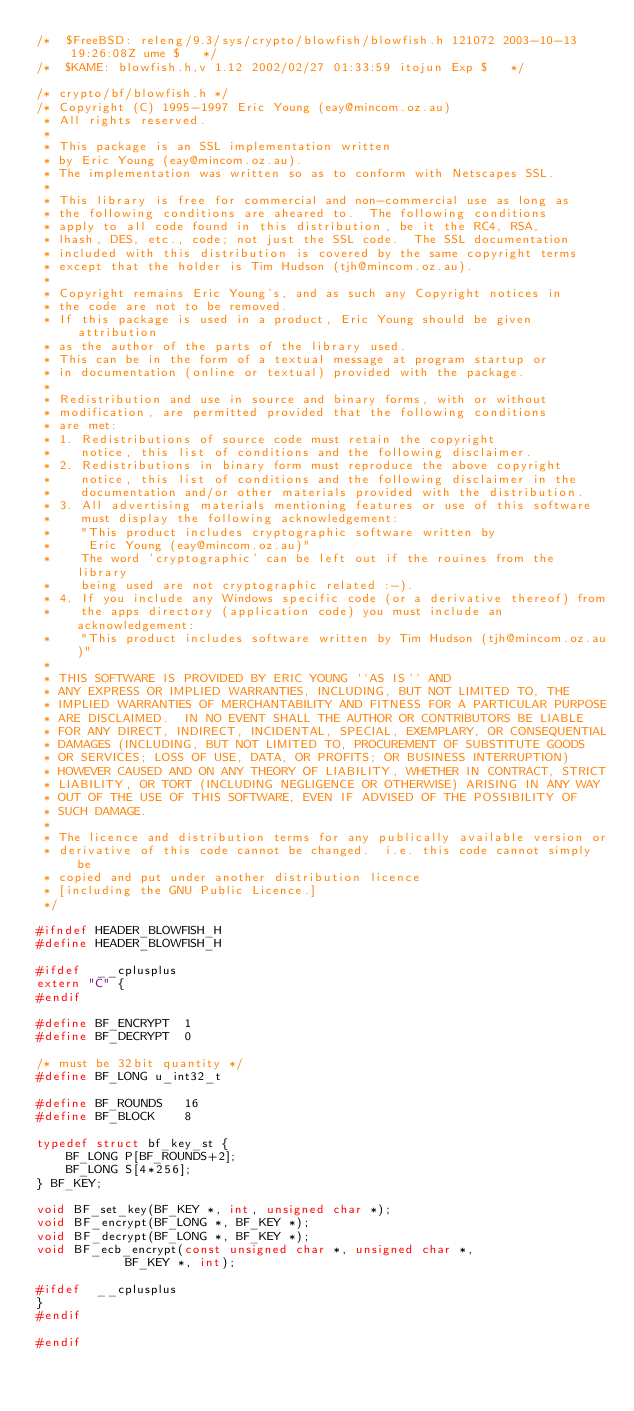Convert code to text. <code><loc_0><loc_0><loc_500><loc_500><_C_>/*	$FreeBSD: releng/9.3/sys/crypto/blowfish/blowfish.h 121072 2003-10-13 19:26:08Z ume $	*/
/*	$KAME: blowfish.h,v 1.12 2002/02/27 01:33:59 itojun Exp $	*/

/* crypto/bf/blowfish.h */
/* Copyright (C) 1995-1997 Eric Young (eay@mincom.oz.au)
 * All rights reserved.
 *
 * This package is an SSL implementation written
 * by Eric Young (eay@mincom.oz.au).
 * The implementation was written so as to conform with Netscapes SSL.
 *
 * This library is free for commercial and non-commercial use as long as
 * the following conditions are aheared to.  The following conditions
 * apply to all code found in this distribution, be it the RC4, RSA,
 * lhash, DES, etc., code; not just the SSL code.  The SSL documentation
 * included with this distribution is covered by the same copyright terms
 * except that the holder is Tim Hudson (tjh@mincom.oz.au).
 *
 * Copyright remains Eric Young's, and as such any Copyright notices in
 * the code are not to be removed.
 * If this package is used in a product, Eric Young should be given attribution
 * as the author of the parts of the library used.
 * This can be in the form of a textual message at program startup or
 * in documentation (online or textual) provided with the package.
 *
 * Redistribution and use in source and binary forms, with or without
 * modification, are permitted provided that the following conditions
 * are met:
 * 1. Redistributions of source code must retain the copyright
 *    notice, this list of conditions and the following disclaimer.
 * 2. Redistributions in binary form must reproduce the above copyright
 *    notice, this list of conditions and the following disclaimer in the
 *    documentation and/or other materials provided with the distribution.
 * 3. All advertising materials mentioning features or use of this software
 *    must display the following acknowledgement:
 *    "This product includes cryptographic software written by
 *     Eric Young (eay@mincom.oz.au)"
 *    The word 'cryptographic' can be left out if the rouines from the library
 *    being used are not cryptographic related :-).
 * 4. If you include any Windows specific code (or a derivative thereof) from
 *    the apps directory (application code) you must include an acknowledgement:
 *    "This product includes software written by Tim Hudson (tjh@mincom.oz.au)"
 *
 * THIS SOFTWARE IS PROVIDED BY ERIC YOUNG ``AS IS'' AND
 * ANY EXPRESS OR IMPLIED WARRANTIES, INCLUDING, BUT NOT LIMITED TO, THE
 * IMPLIED WARRANTIES OF MERCHANTABILITY AND FITNESS FOR A PARTICULAR PURPOSE
 * ARE DISCLAIMED.  IN NO EVENT SHALL THE AUTHOR OR CONTRIBUTORS BE LIABLE
 * FOR ANY DIRECT, INDIRECT, INCIDENTAL, SPECIAL, EXEMPLARY, OR CONSEQUENTIAL
 * DAMAGES (INCLUDING, BUT NOT LIMITED TO, PROCUREMENT OF SUBSTITUTE GOODS
 * OR SERVICES; LOSS OF USE, DATA, OR PROFITS; OR BUSINESS INTERRUPTION)
 * HOWEVER CAUSED AND ON ANY THEORY OF LIABILITY, WHETHER IN CONTRACT, STRICT
 * LIABILITY, OR TORT (INCLUDING NEGLIGENCE OR OTHERWISE) ARISING IN ANY WAY
 * OUT OF THE USE OF THIS SOFTWARE, EVEN IF ADVISED OF THE POSSIBILITY OF
 * SUCH DAMAGE.
 *
 * The licence and distribution terms for any publically available version or
 * derivative of this code cannot be changed.  i.e. this code cannot simply be
 * copied and put under another distribution licence
 * [including the GNU Public Licence.]
 */

#ifndef HEADER_BLOWFISH_H
#define HEADER_BLOWFISH_H

#ifdef  __cplusplus
extern "C" {
#endif

#define BF_ENCRYPT	1
#define BF_DECRYPT	0

/* must be 32bit quantity */
#define BF_LONG u_int32_t

#define BF_ROUNDS	16
#define BF_BLOCK	8

typedef struct bf_key_st {
	BF_LONG P[BF_ROUNDS+2];
	BF_LONG S[4*256];
} BF_KEY;

void BF_set_key(BF_KEY *, int, unsigned char *);
void BF_encrypt(BF_LONG *, BF_KEY *);
void BF_decrypt(BF_LONG *, BF_KEY *);
void BF_ecb_encrypt(const unsigned char *, unsigned char *,
		    BF_KEY *, int);

#ifdef  __cplusplus
}
#endif

#endif
</code> 